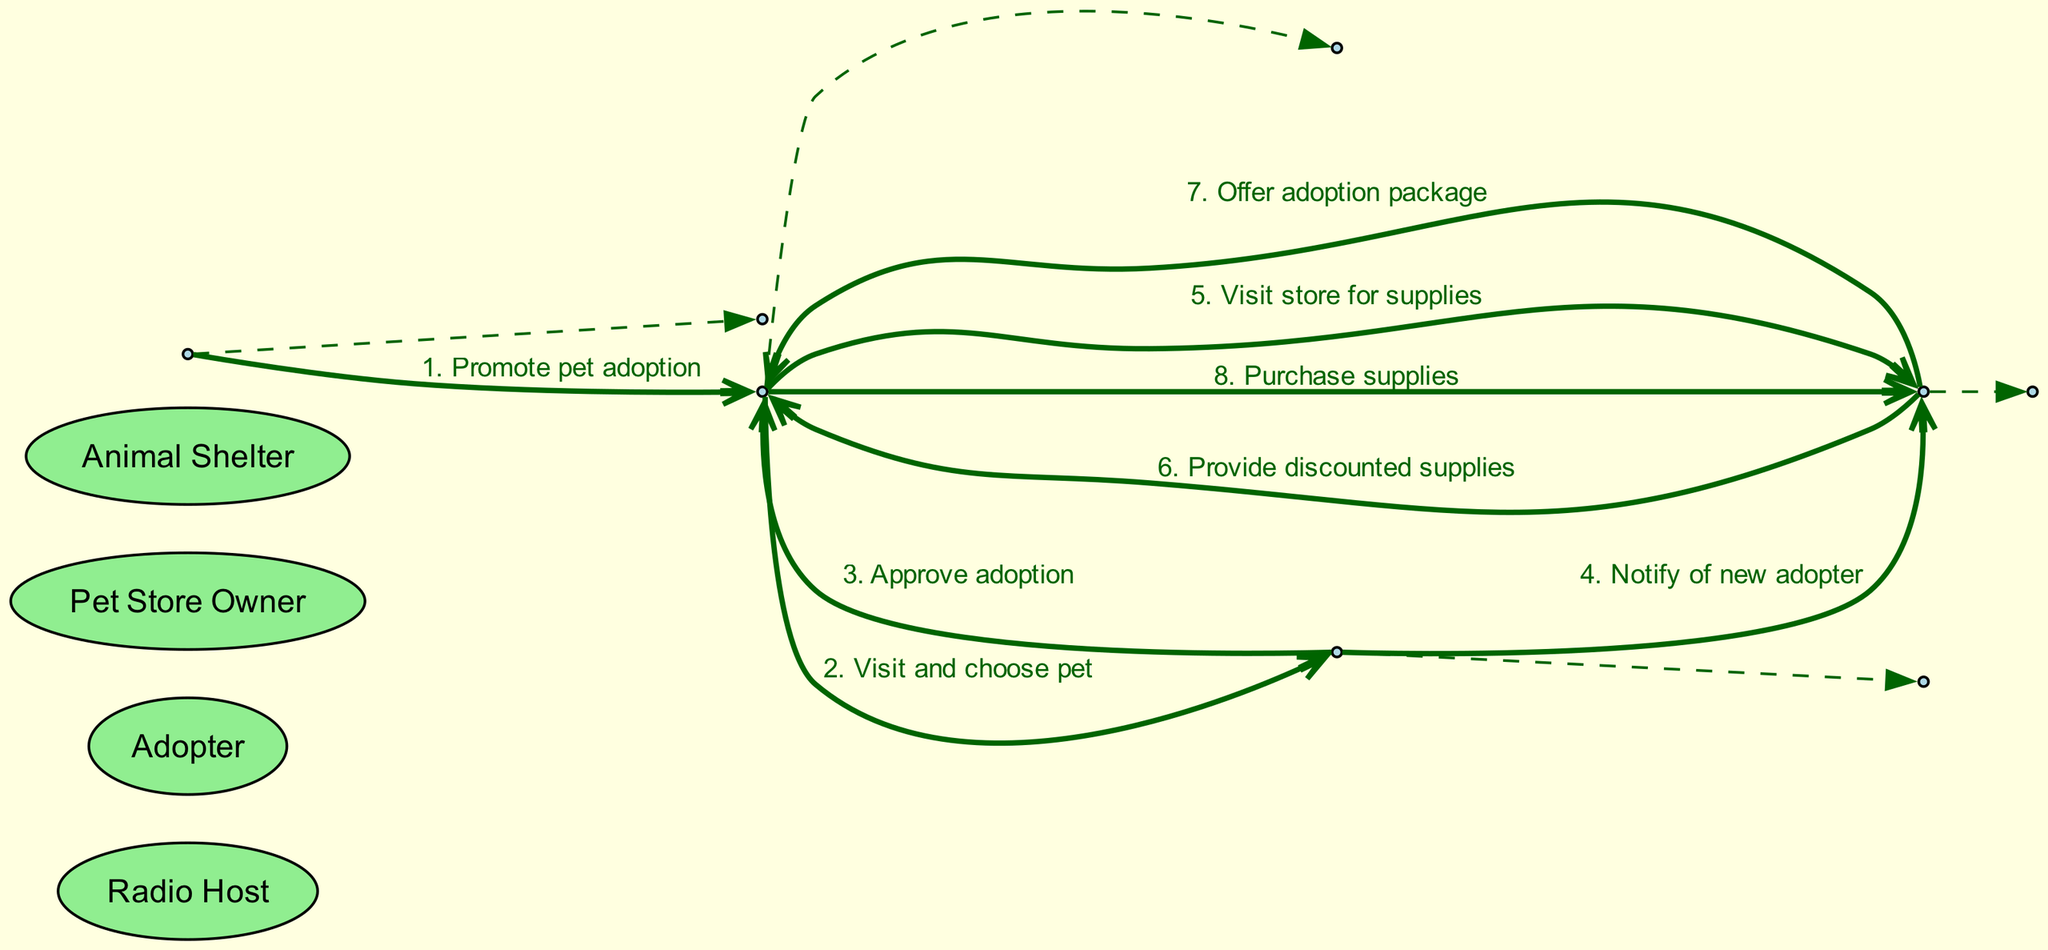What is the first message in the sequence? The first message is from the Radio Host to the Adopter, promoting pet adoption. Thus, it is established that the Radio Host initiates the sequence by informing the Adopter about pet adoption.
Answer: Promote pet adoption How many actors are involved in the diagram? The diagram includes four distinct actors: the Radio Host, Adopter, Pet Store Owner, and Animal Shelter. Counting each actor shows that there are four participants involved in the pet adoption process.
Answer: Four What is the second message sent to the Animal Shelter? The second message sent to the Animal Shelter is from the Adopter, indicating their action of visiting and choosing a pet. It highlights the personal engagement of the Adopter in the process after being informed by the Radio Host.
Answer: Visit and choose pet Who notifies the Pet Store Owner about the new adopter? The notification of the new adopter is sent by the Animal Shelter to the Pet Store Owner. This step is crucial as it connects the Animal Shelter's actions to informing the Pet Store Owner about the adoption process.
Answer: Animal Shelter What happens after the Pet Store Owner provides discounted supplies? After providing discounted supplies, the Pet Store Owner also offers an adoption package to the Adopter. This points to the added value and support that the Pet Store Owner provides following the supply pickup.
Answer: Offer adoption package Which actor receives the first message? The first message is received by the Adopter from the Radio Host, marking the beginning of the adoption process and establishing a channel of communication encouraging pet adoption.
Answer: Adopter How many messages does the Adopter send in the process? The Adopter sends two messages in the process: one to the Animal Shelter for choosing a pet, and another to the Pet Store Owner for visiting the store. This illustrates the active role of the Adopter in the interactions required for pet adoption.
Answer: Two What is the last message in the sequence? The last message is from the Adopter to the Pet Store Owner, indicating the completion of the process where the Adopter purchases supplies for their new pet, finalizing their experience at the Pet Store.
Answer: Purchase supplies 